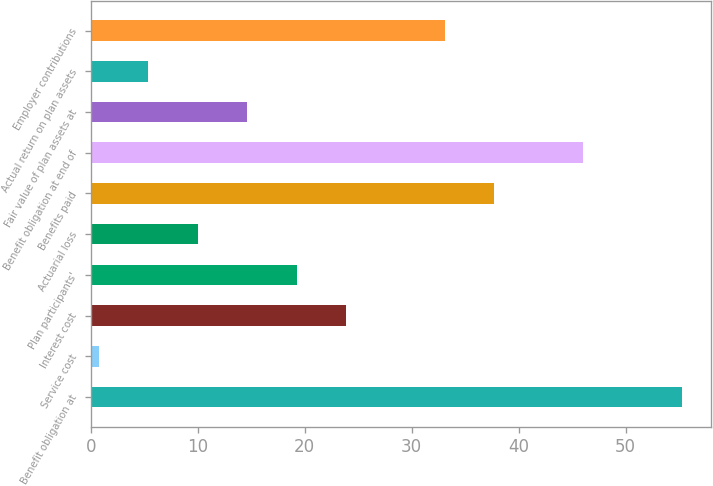Convert chart to OTSL. <chart><loc_0><loc_0><loc_500><loc_500><bar_chart><fcel>Benefit obligation at<fcel>Service cost<fcel>Interest cost<fcel>Plan participants'<fcel>Actuarial loss<fcel>Benefits paid<fcel>Benefit obligation at end of<fcel>Fair value of plan assets at<fcel>Actual return on plan assets<fcel>Employer contributions<nl><fcel>55.24<fcel>0.76<fcel>23.86<fcel>19.24<fcel>10<fcel>37.72<fcel>46<fcel>14.62<fcel>5.38<fcel>33.1<nl></chart> 